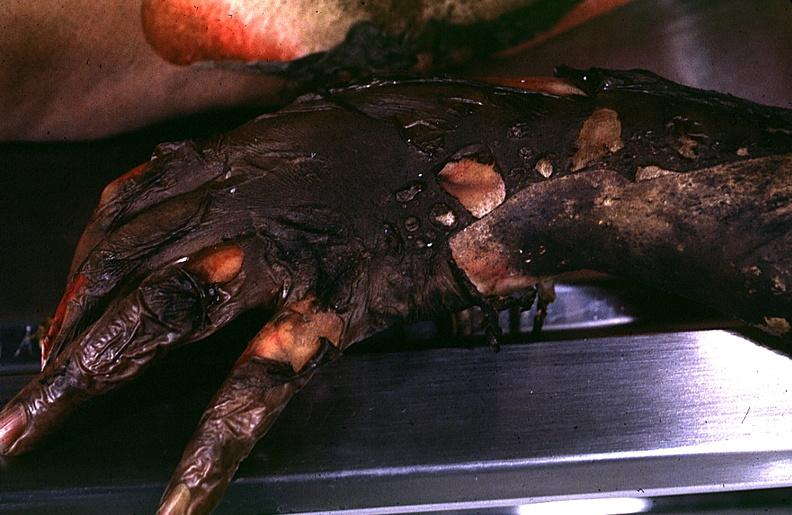does this image show thermal burn?
Answer the question using a single word or phrase. Yes 